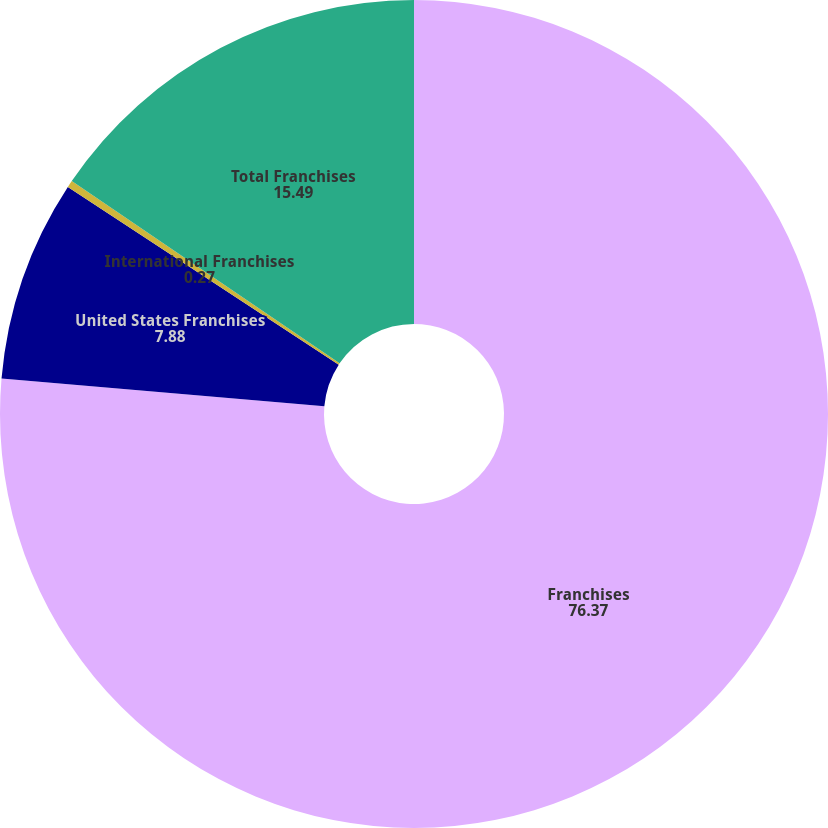Convert chart to OTSL. <chart><loc_0><loc_0><loc_500><loc_500><pie_chart><fcel>Franchises<fcel>United States Franchises<fcel>International Franchises<fcel>Total Franchises<nl><fcel>76.37%<fcel>7.88%<fcel>0.27%<fcel>15.49%<nl></chart> 